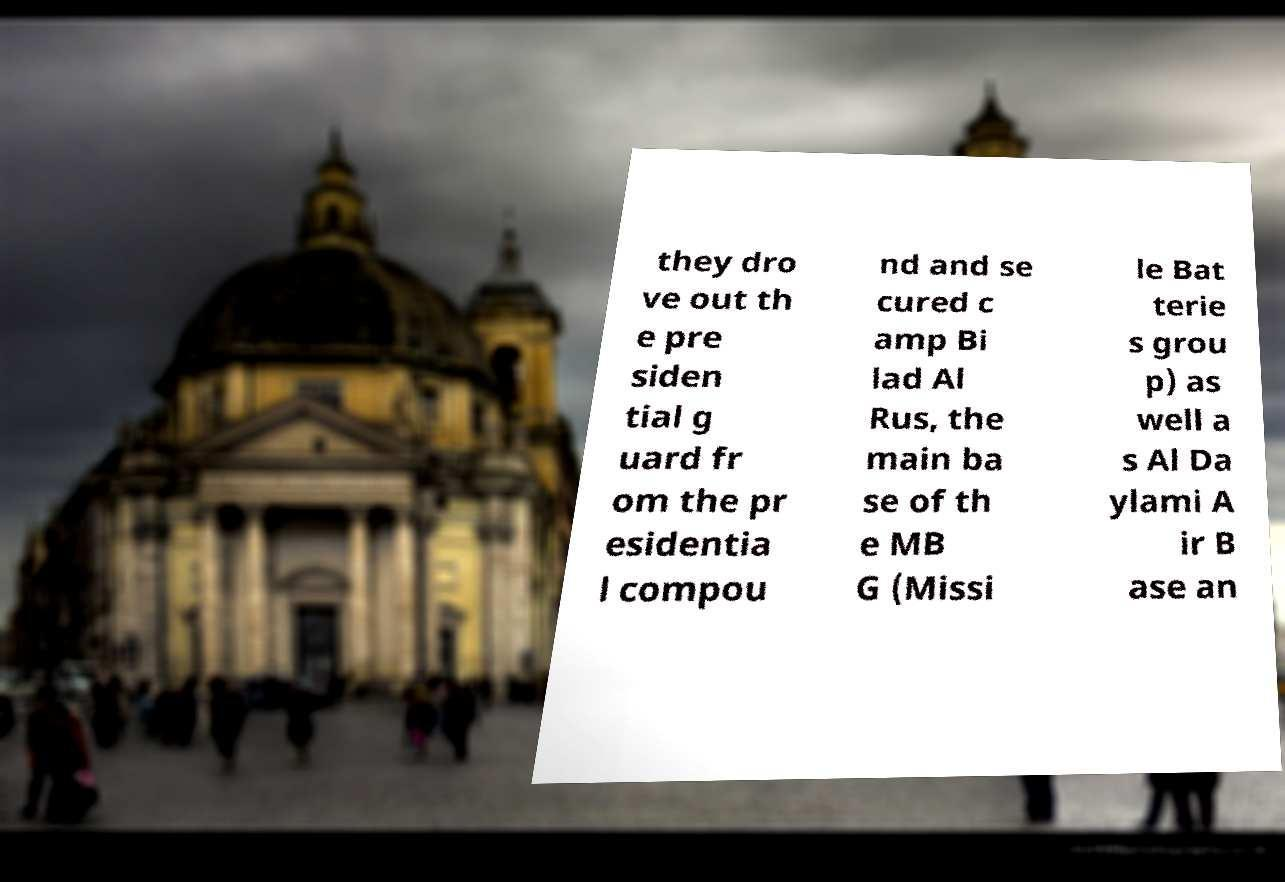Can you accurately transcribe the text from the provided image for me? they dro ve out th e pre siden tial g uard fr om the pr esidentia l compou nd and se cured c amp Bi lad Al Rus, the main ba se of th e MB G (Missi le Bat terie s grou p) as well a s Al Da ylami A ir B ase an 